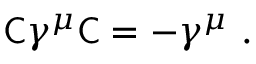<formula> <loc_0><loc_0><loc_500><loc_500>{ C } \gamma ^ { \mu } { C } = - \gamma ^ { \mu } .</formula> 